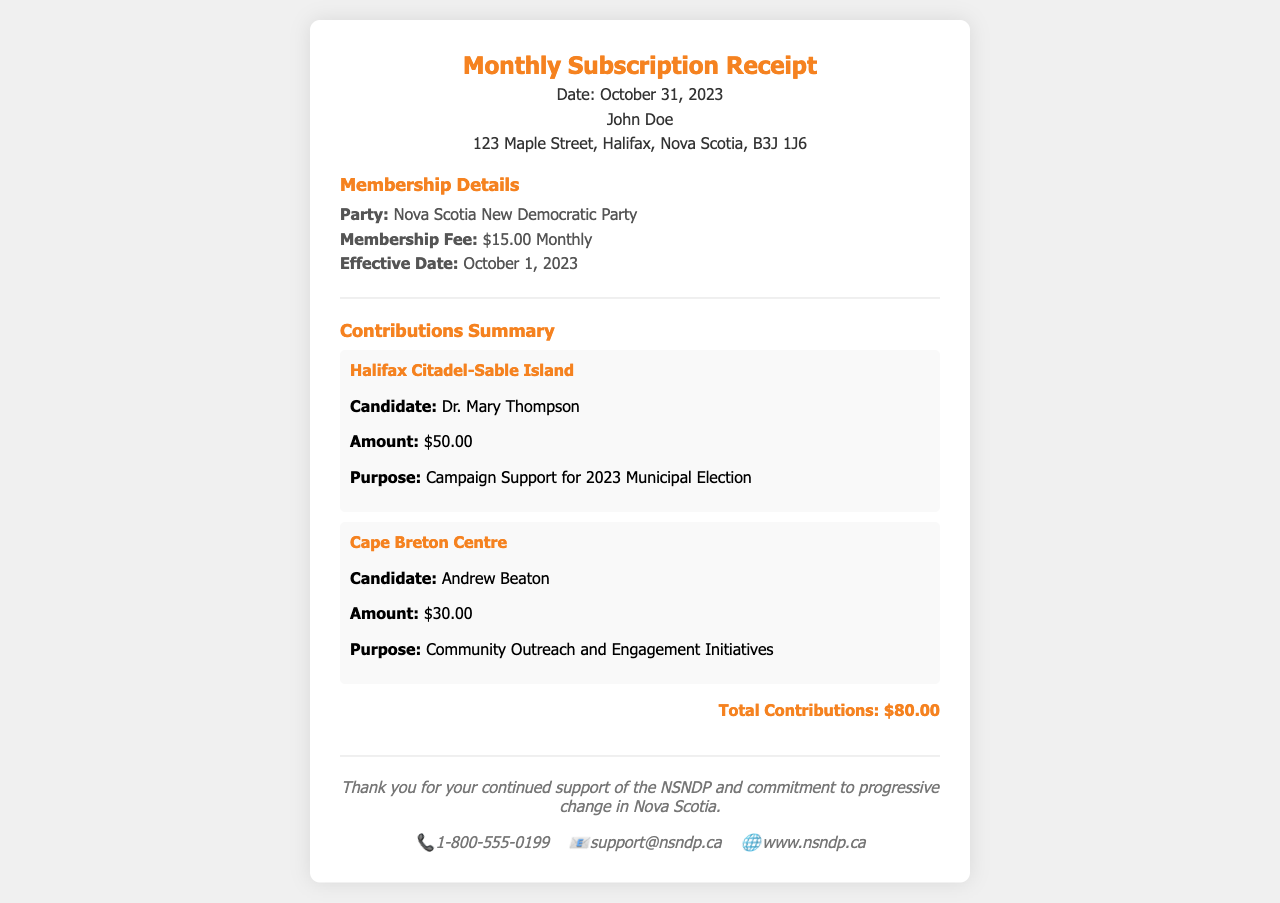What is the date of the receipt? The date of the receipt is clearly stated in the header section, which reads October 31, 2023.
Answer: October 31, 2023 Who is the member listed on the receipt? The member's name is mentioned in the header as John Doe.
Answer: John Doe What is the membership fee? The membership fee is specified under Membership Details as $15.00 Monthly.
Answer: $15.00 Monthly How much was contributed to the Halifax Citadel-Sable Island campaign? The contribution to the Halifax Citadel-Sable Island campaign is listed as $50.00.
Answer: $50.00 What is the total amount of contributions made? The total amount of contributions is calculated and stated at the end of the Contributions Summary as $80.00.
Answer: $80.00 What is the purpose of the contribution to Cape Breton Centre? The purpose of the contribution to Cape Breton Centre is detailed as Community Outreach and Engagement Initiatives.
Answer: Community Outreach and Engagement Initiatives Who is the candidate for the campaign in Halifax Citadel-Sable Island? The candidate for the Halifax Citadel-Sable Island campaign is named as Dr. Mary Thompson.
Answer: Dr. Mary Thompson What is the effective date of the membership? The effective date of the membership is mentioned under Membership Details as October 1, 2023.
Answer: October 1, 2023 What contact method is provided in the footer? Multiple contact methods are provided, including a phone number, email, and website, which indicates various ways to reach out for support.
Answer: 1-800-555-0199, support@nsndp.ca, www.nsndp.ca 